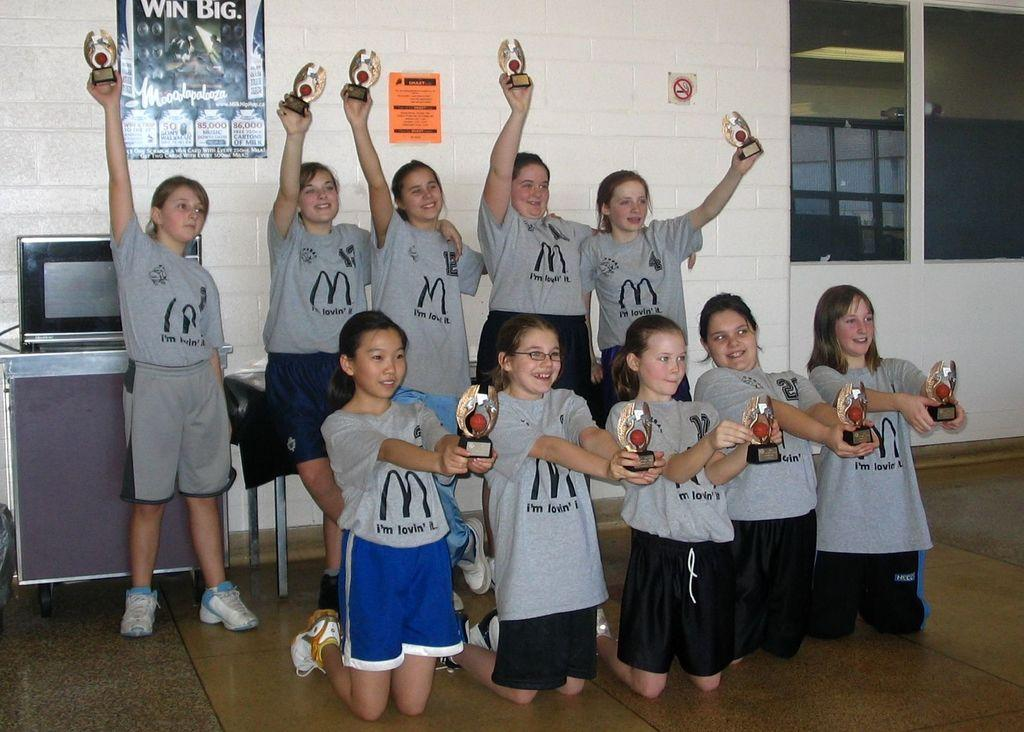<image>
Provide a brief description of the given image. two rows of girls wearing gray mcdonalds tshirts holding trophies 